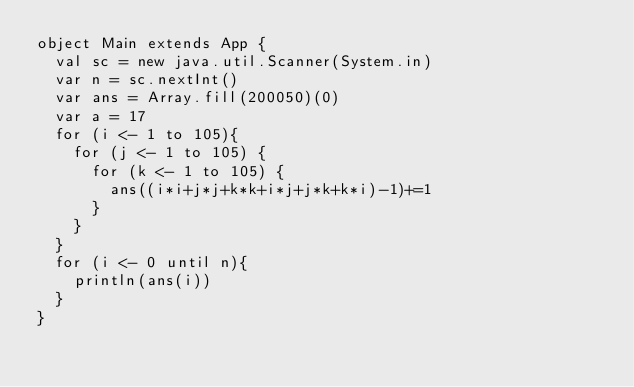<code> <loc_0><loc_0><loc_500><loc_500><_Scala_>object Main extends App {
  val sc = new java.util.Scanner(System.in)
  var n = sc.nextInt()
  var ans = Array.fill(200050)(0)
  var a = 17
  for (i <- 1 to 105){
    for (j <- 1 to 105) {
      for (k <- 1 to 105) {
        ans((i*i+j*j+k*k+i*j+j*k+k*i)-1)+=1
      }
    }
  }
  for (i <- 0 until n){
    println(ans(i))
  }
}
</code> 